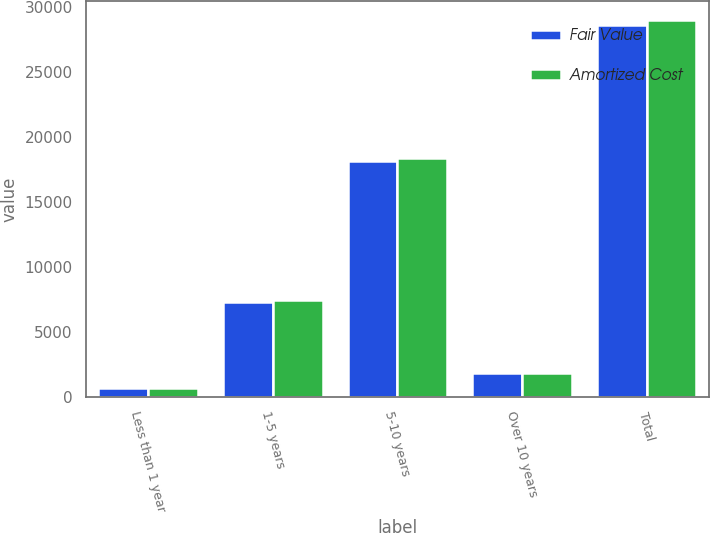Convert chart. <chart><loc_0><loc_0><loc_500><loc_500><stacked_bar_chart><ecel><fcel>Less than 1 year<fcel>1-5 years<fcel>5-10 years<fcel>Over 10 years<fcel>Total<nl><fcel>Fair Value<fcel>695<fcel>7277<fcel>18191<fcel>1812<fcel>28678<nl><fcel>Amortized Cost<fcel>707<fcel>7441<fcel>18372<fcel>1821<fcel>29044<nl></chart> 